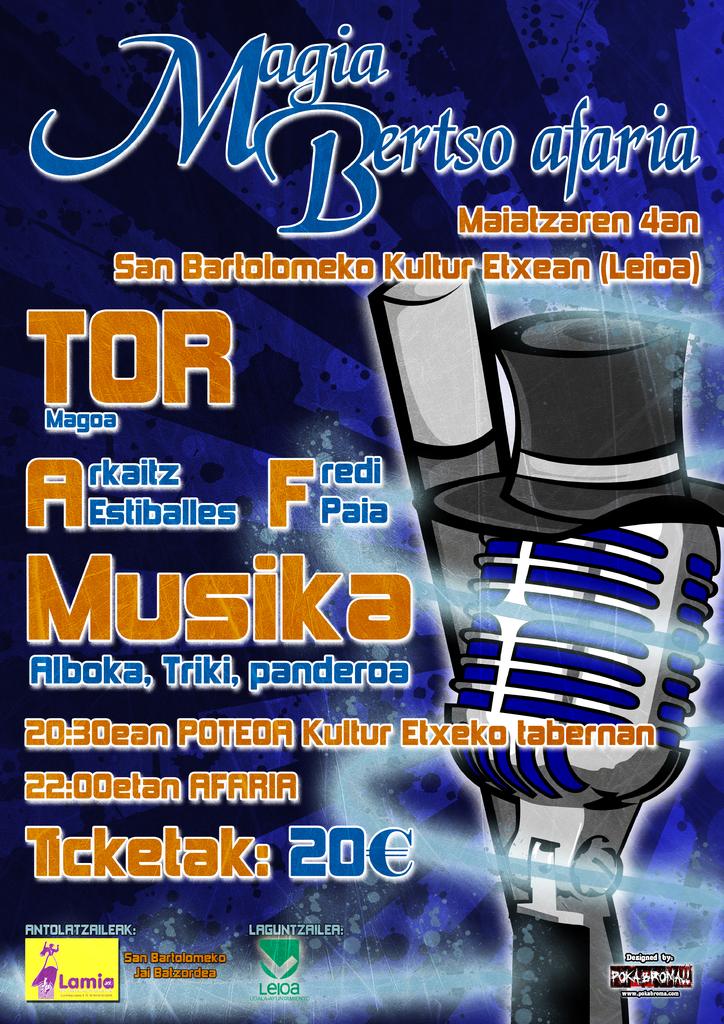What is the uppermost word written on this flyer?
Your response must be concise. Magia. What is the cost on the magazine?
Your answer should be very brief. 20. 